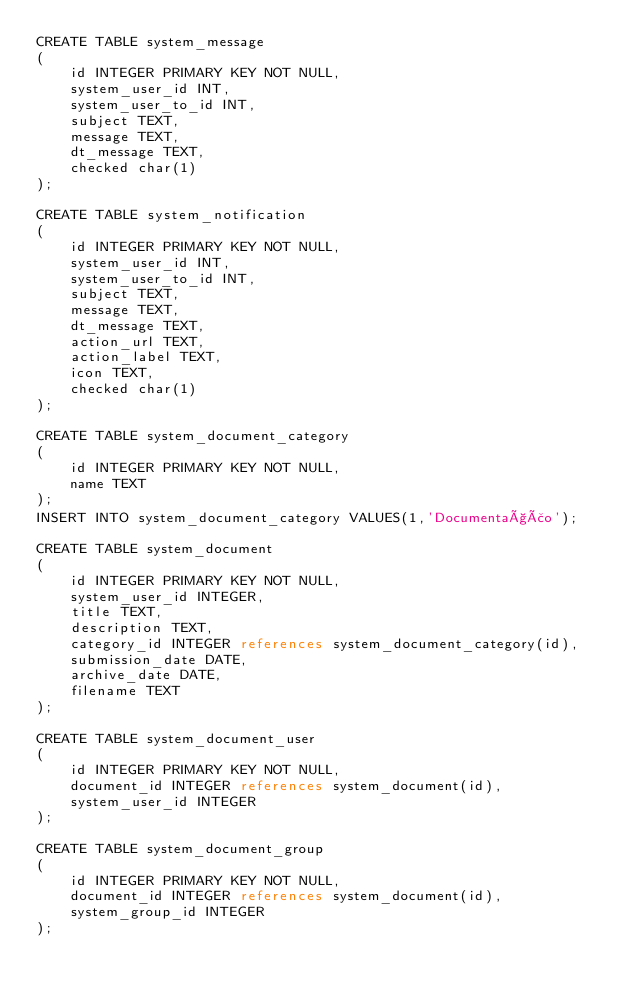Convert code to text. <code><loc_0><loc_0><loc_500><loc_500><_SQL_>CREATE TABLE system_message
(
    id INTEGER PRIMARY KEY NOT NULL,
    system_user_id INT,
    system_user_to_id INT,
    subject TEXT,
    message TEXT,
    dt_message TEXT,
    checked char(1)
);

CREATE TABLE system_notification
(
    id INTEGER PRIMARY KEY NOT NULL,
    system_user_id INT,
    system_user_to_id INT,
    subject TEXT,
    message TEXT,
    dt_message TEXT,
    action_url TEXT,
    action_label TEXT,
    icon TEXT,
    checked char(1)
);

CREATE TABLE system_document_category
(
    id INTEGER PRIMARY KEY NOT NULL,
    name TEXT
);
INSERT INTO system_document_category VALUES(1,'Documentação');

CREATE TABLE system_document
(
    id INTEGER PRIMARY KEY NOT NULL,
    system_user_id INTEGER,
    title TEXT,
    description TEXT,
    category_id INTEGER references system_document_category(id),
    submission_date DATE,
    archive_date DATE,
    filename TEXT
);

CREATE TABLE system_document_user
(
    id INTEGER PRIMARY KEY NOT NULL,
    document_id INTEGER references system_document(id),
    system_user_id INTEGER
);

CREATE TABLE system_document_group
(
    id INTEGER PRIMARY KEY NOT NULL,
    document_id INTEGER references system_document(id),
    system_group_id INTEGER
);
</code> 